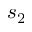<formula> <loc_0><loc_0><loc_500><loc_500>s _ { 2 }</formula> 